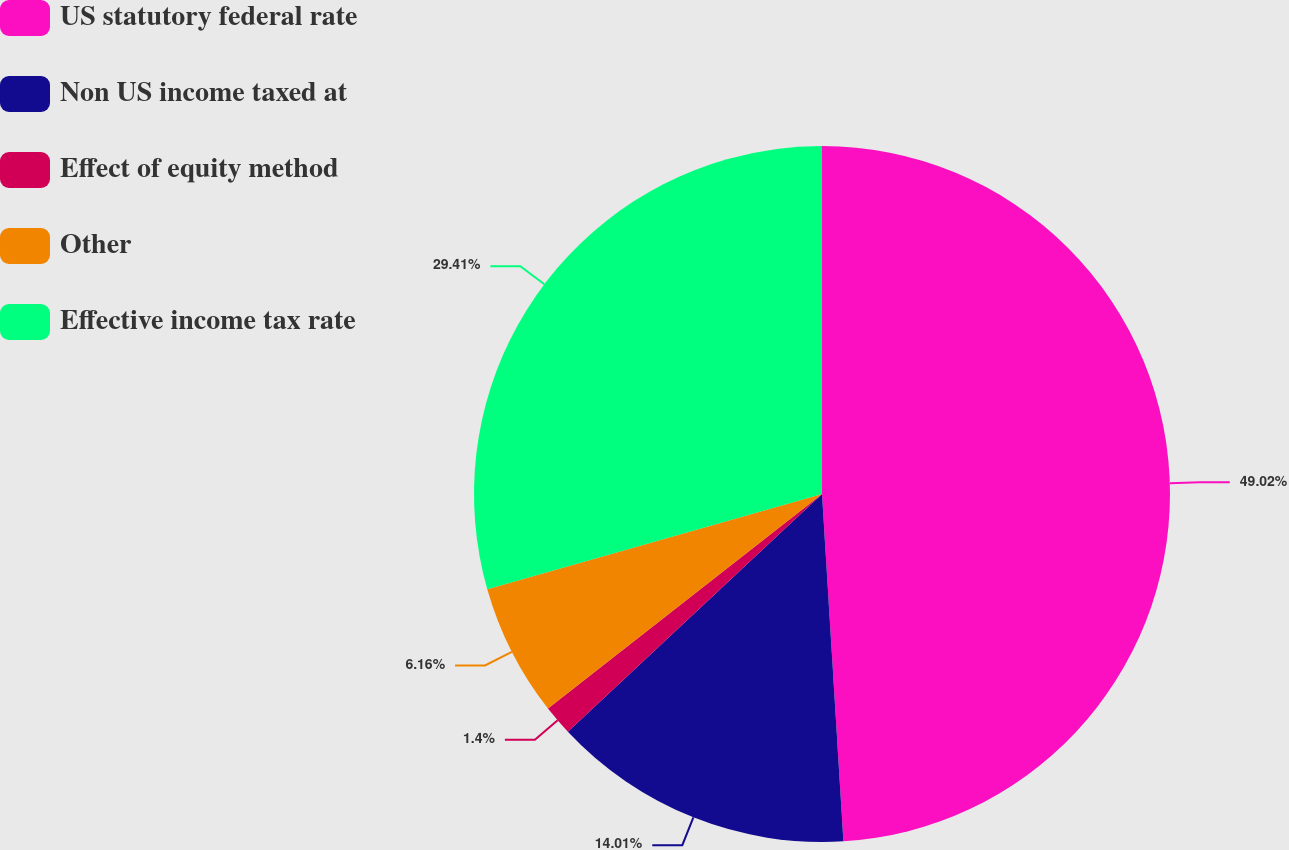Convert chart to OTSL. <chart><loc_0><loc_0><loc_500><loc_500><pie_chart><fcel>US statutory federal rate<fcel>Non US income taxed at<fcel>Effect of equity method<fcel>Other<fcel>Effective income tax rate<nl><fcel>49.02%<fcel>14.01%<fcel>1.4%<fcel>6.16%<fcel>29.41%<nl></chart> 